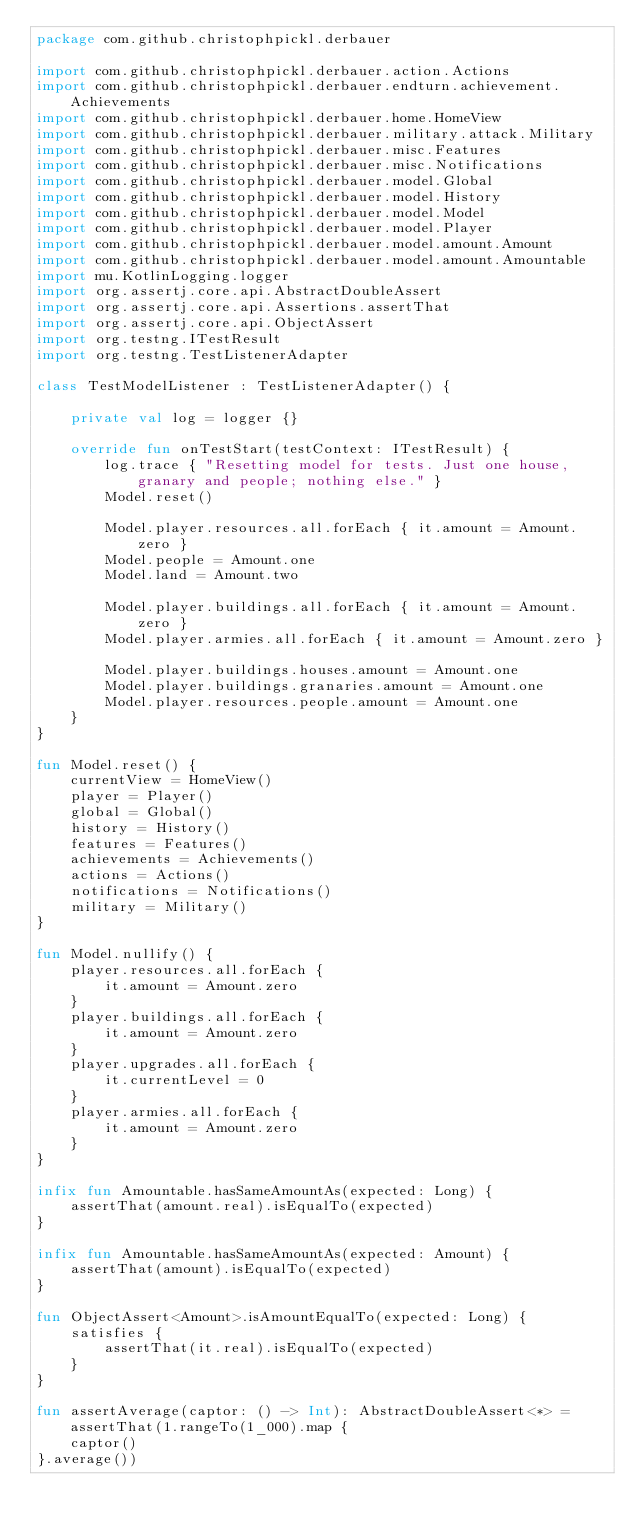Convert code to text. <code><loc_0><loc_0><loc_500><loc_500><_Kotlin_>package com.github.christophpickl.derbauer

import com.github.christophpickl.derbauer.action.Actions
import com.github.christophpickl.derbauer.endturn.achievement.Achievements
import com.github.christophpickl.derbauer.home.HomeView
import com.github.christophpickl.derbauer.military.attack.Military
import com.github.christophpickl.derbauer.misc.Features
import com.github.christophpickl.derbauer.misc.Notifications
import com.github.christophpickl.derbauer.model.Global
import com.github.christophpickl.derbauer.model.History
import com.github.christophpickl.derbauer.model.Model
import com.github.christophpickl.derbauer.model.Player
import com.github.christophpickl.derbauer.model.amount.Amount
import com.github.christophpickl.derbauer.model.amount.Amountable
import mu.KotlinLogging.logger
import org.assertj.core.api.AbstractDoubleAssert
import org.assertj.core.api.Assertions.assertThat
import org.assertj.core.api.ObjectAssert
import org.testng.ITestResult
import org.testng.TestListenerAdapter

class TestModelListener : TestListenerAdapter() {

    private val log = logger {}
    
    override fun onTestStart(testContext: ITestResult) {
        log.trace { "Resetting model for tests. Just one house, granary and people; nothing else." }
        Model.reset()

        Model.player.resources.all.forEach { it.amount = Amount.zero }
        Model.people = Amount.one
        Model.land = Amount.two

        Model.player.buildings.all.forEach { it.amount = Amount.zero }
        Model.player.armies.all.forEach { it.amount = Amount.zero }

        Model.player.buildings.houses.amount = Amount.one
        Model.player.buildings.granaries.amount = Amount.one
        Model.player.resources.people.amount = Amount.one
    }
}

fun Model.reset() {
    currentView = HomeView()
    player = Player()
    global = Global()
    history = History()
    features = Features()
    achievements = Achievements()
    actions = Actions()
    notifications = Notifications()
    military = Military()
}

fun Model.nullify() {
    player.resources.all.forEach {
        it.amount = Amount.zero
    }
    player.buildings.all.forEach {
        it.amount = Amount.zero
    }
    player.upgrades.all.forEach {
        it.currentLevel = 0
    }
    player.armies.all.forEach {
        it.amount = Amount.zero
    }
}

infix fun Amountable.hasSameAmountAs(expected: Long) {
    assertThat(amount.real).isEqualTo(expected)
}

infix fun Amountable.hasSameAmountAs(expected: Amount) {
    assertThat(amount).isEqualTo(expected)
}

fun ObjectAssert<Amount>.isAmountEqualTo(expected: Long) {
    satisfies {
        assertThat(it.real).isEqualTo(expected)
    }
}

fun assertAverage(captor: () -> Int): AbstractDoubleAssert<*> = assertThat(1.rangeTo(1_000).map {
    captor()
}.average())
</code> 